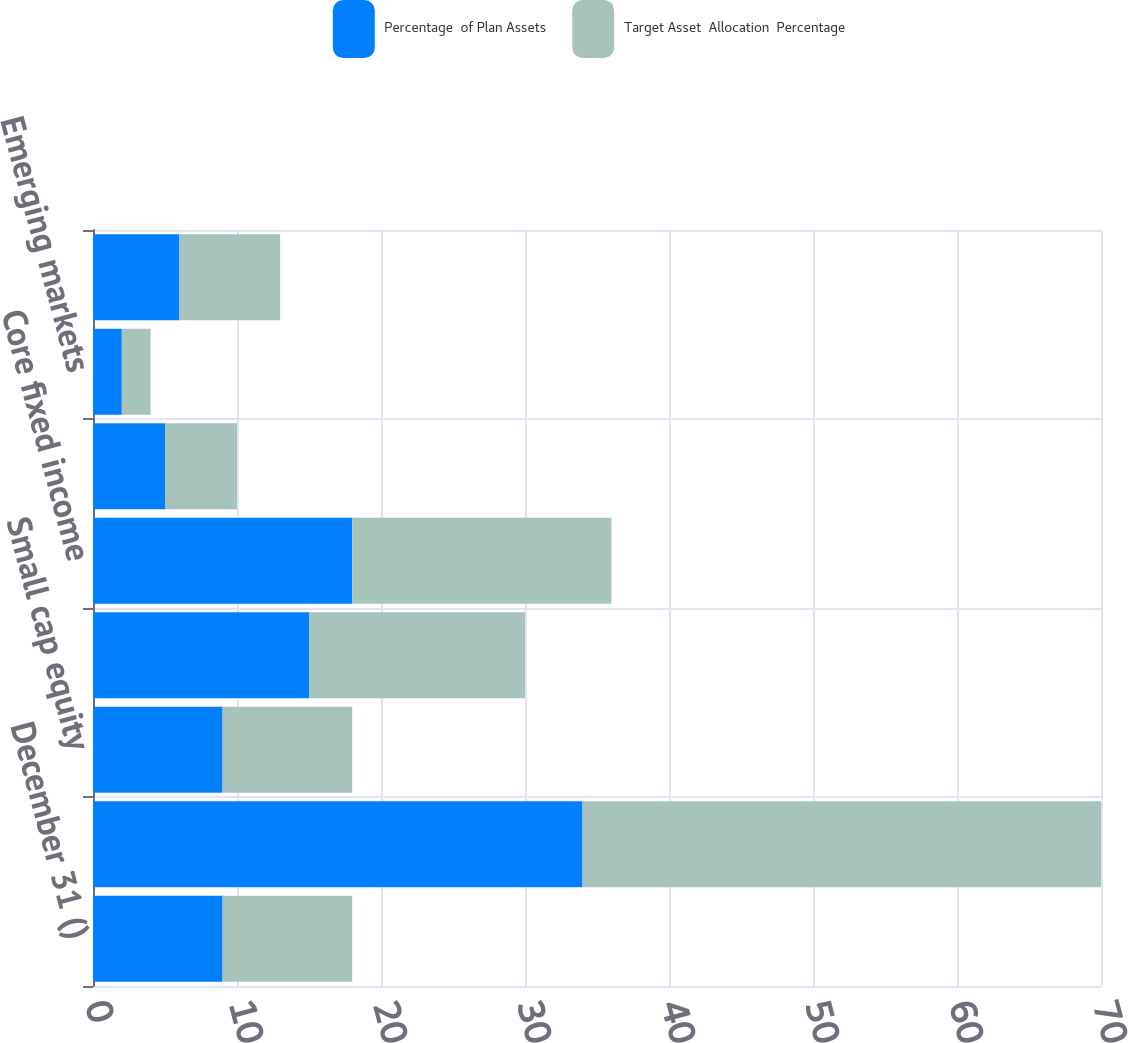<chart> <loc_0><loc_0><loc_500><loc_500><stacked_bar_chart><ecel><fcel>December 31 ()<fcel>Large cap equity<fcel>Small cap equity<fcel>International equity<fcel>Core fixed income<fcel>High-yield bonds<fcel>Emerging markets<fcel>Real estate<nl><fcel>Percentage  of Plan Assets<fcel>9<fcel>34<fcel>9<fcel>15<fcel>18<fcel>5<fcel>2<fcel>6<nl><fcel>Target Asset  Allocation  Percentage<fcel>9<fcel>36<fcel>9<fcel>15<fcel>18<fcel>5<fcel>2<fcel>7<nl></chart> 